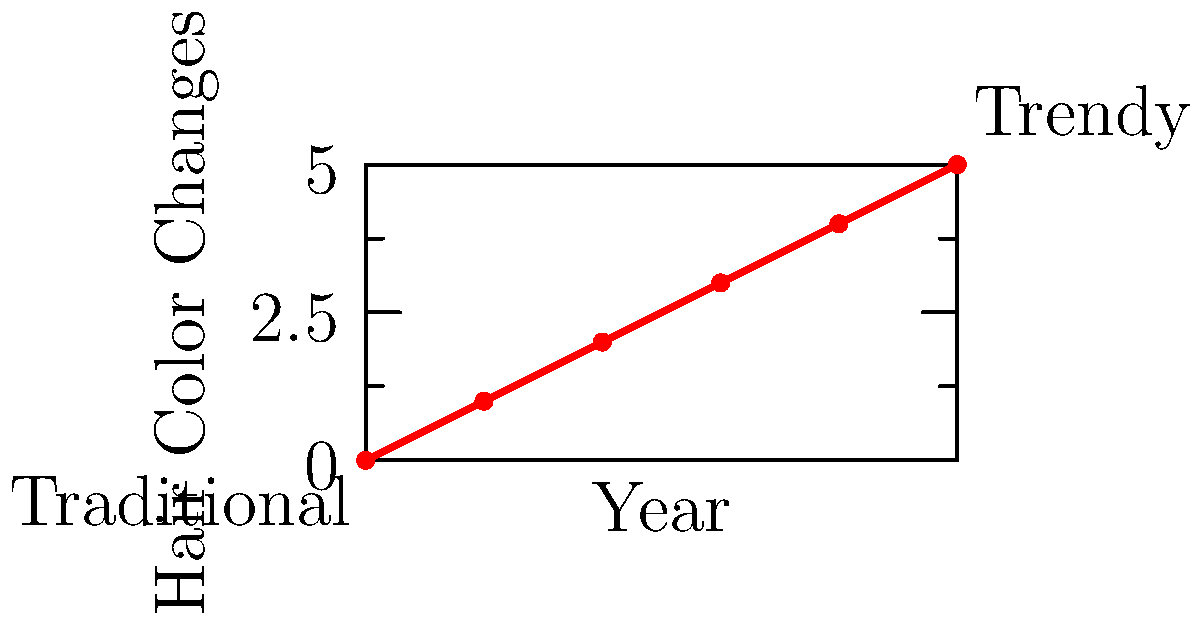Based on the graph showing hair color changes over time, what trend can be observed in the hairstylist's creativity from 2010 to 2020, and how might this impact a conservative parent's preference for traditional styles? To answer this question, let's analyze the graph step-by-step:

1. The x-axis represents years from 2010 to 2020.
2. The y-axis represents the number of hair color changes, which can be interpreted as a measure of creativity or trendiness.
3. In 2010, the graph starts at 0, indicating a traditional style with no color changes.
4. As we move from left to right on the graph, we see a steady increase in the number of hair color changes.
5. By 2020, the graph reaches 5 hair color changes, indicating a significant increase in creative or trendy styles.
6. The trend shows a linear increase in hair color changes over time, suggesting the hairstylist is becoming more experimental and less traditional.

For a conservative parent who prefers traditional styles:
- This trend might be concerning as it moves away from the familiar and conservative looks they prefer.
- The increasing number of color changes may be viewed as too bold or unconventional for their taste.
- While they may admire the creativity, they might find it challenging to embrace these evolving trends for themselves or their family members.
Answer: Steady increase in trendy styles, potentially conflicting with conservative preferences 